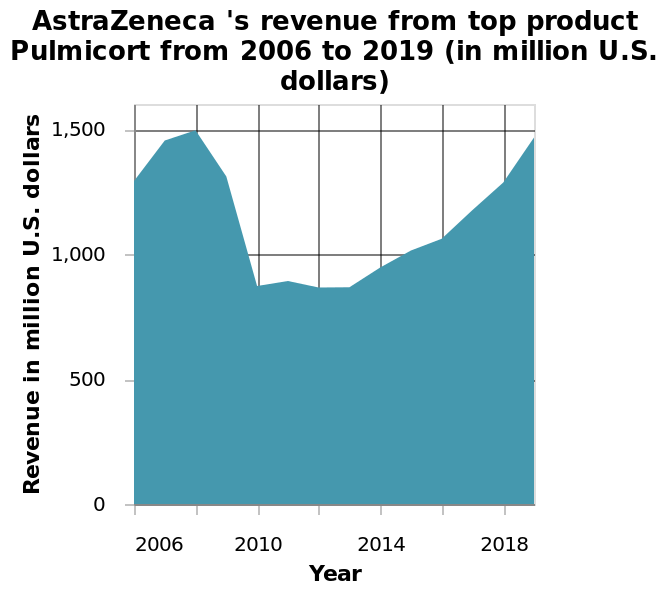<image>
Did Astra Zeneca's revenue increase or decrease after 2013? Astra Zeneca's revenue slowly inclined after 2013. please summary the statistics and relations of the chart Between 2010 and 2013 Astra Zenecas revenue stayed at a steady level after a massive drop in 2008, and then slowly inclined going towards 2019. What is depicted on the y-axis of the AstraZeneca revenue diagram?  The y-axis represents the revenue in million U.S. dollars. 